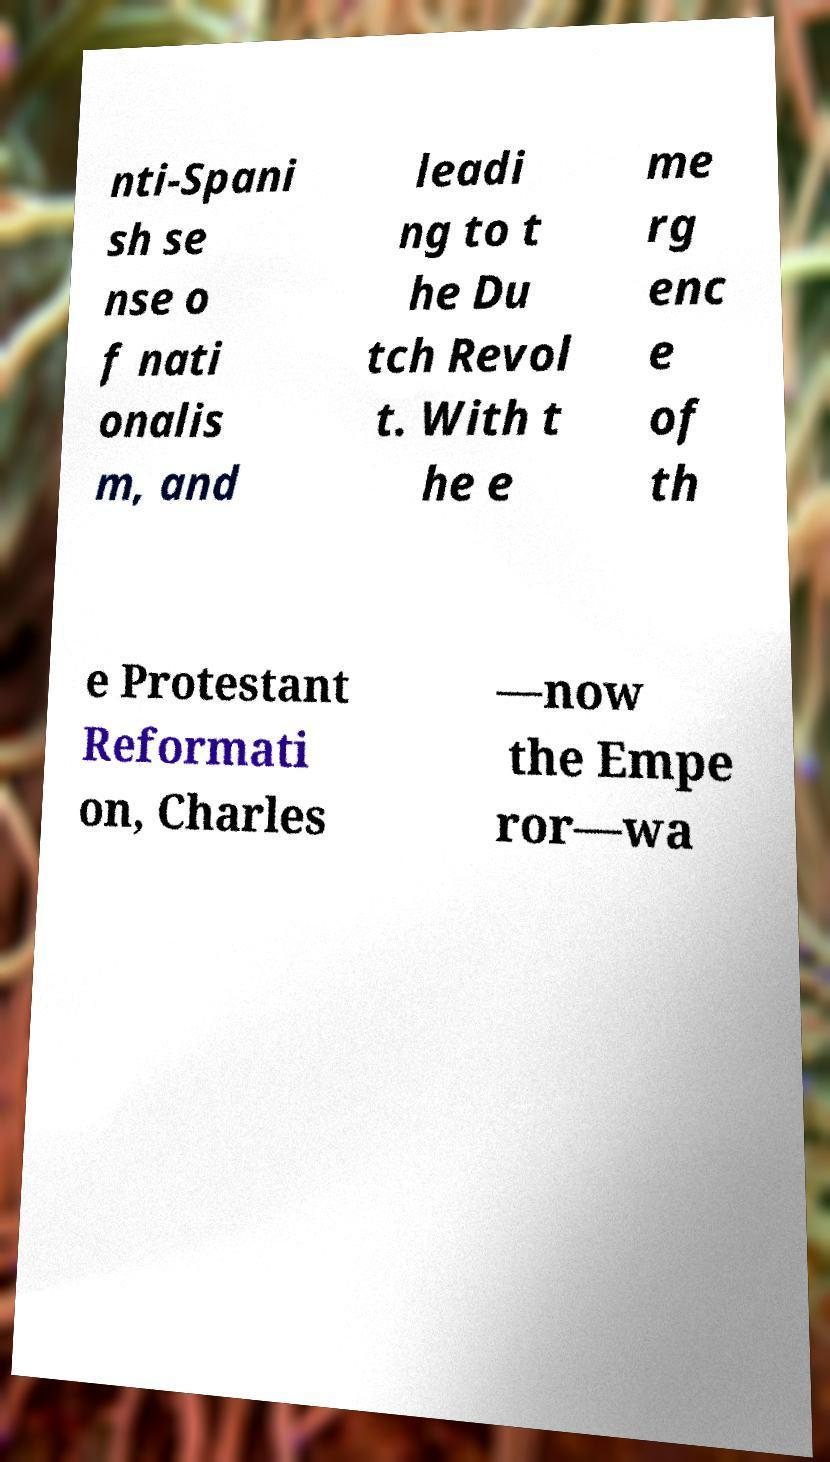Could you extract and type out the text from this image? nti-Spani sh se nse o f nati onalis m, and leadi ng to t he Du tch Revol t. With t he e me rg enc e of th e Protestant Reformati on, Charles —now the Empe ror—wa 